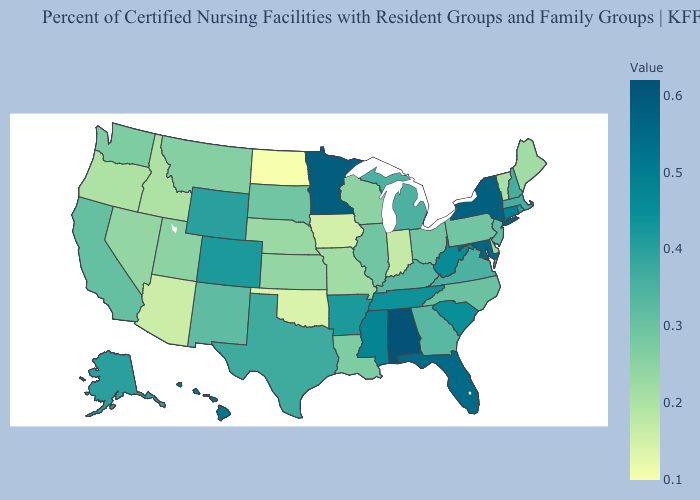Among the states that border Washington , which have the lowest value?
Answer briefly. Idaho, Oregon. Does North Dakota have the lowest value in the USA?
Concise answer only. Yes. Which states have the highest value in the USA?
Quick response, please. Alabama. 